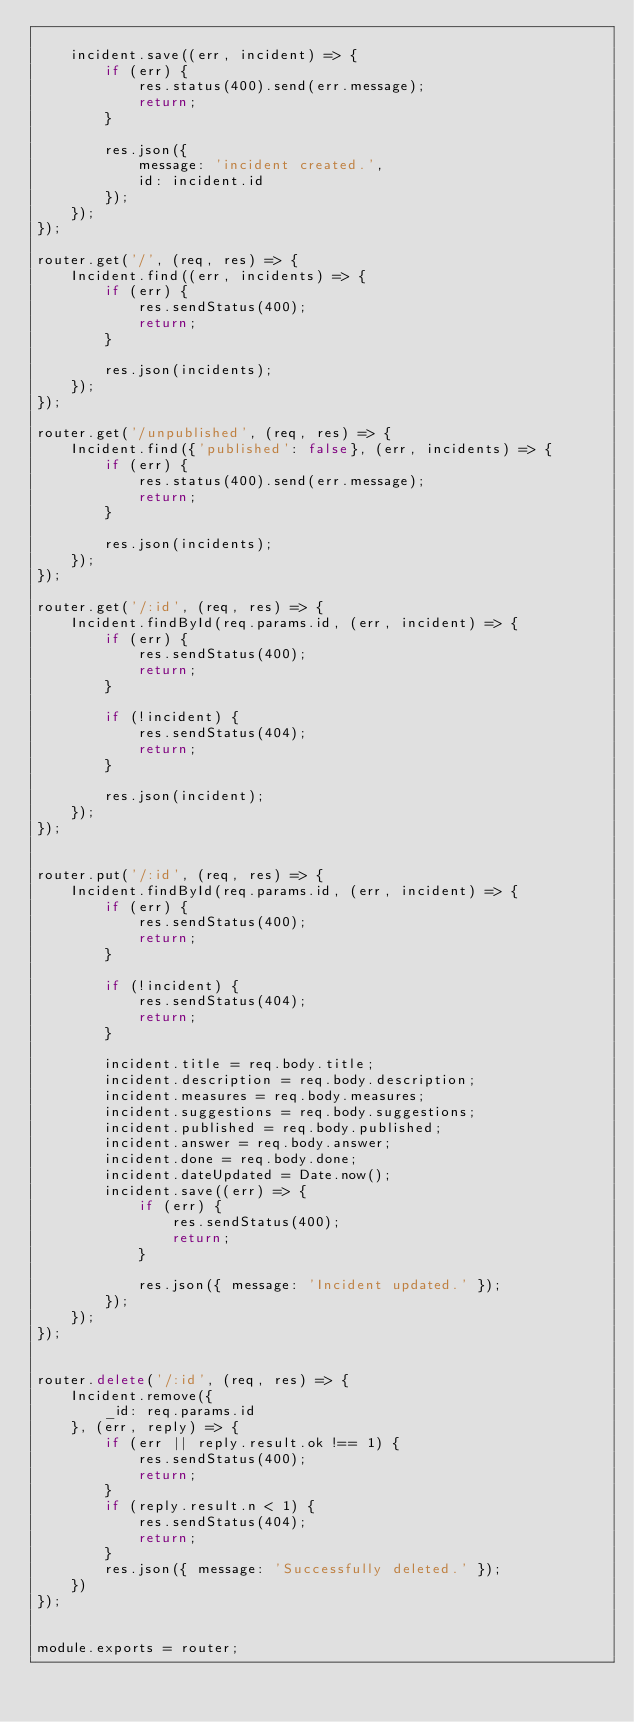<code> <loc_0><loc_0><loc_500><loc_500><_JavaScript_>
    incident.save((err, incident) => {
        if (err) {
            res.status(400).send(err.message);
            return;
        }

        res.json({
            message: 'incident created.',
            id: incident.id
        });
    });
});

router.get('/', (req, res) => {
    Incident.find((err, incidents) => {
        if (err) {
            res.sendStatus(400);
            return;
        }

        res.json(incidents);
    });
});

router.get('/unpublished', (req, res) => {
    Incident.find({'published': false}, (err, incidents) => {
        if (err) {
            res.status(400).send(err.message);
            return;
        }

        res.json(incidents);
    });
});

router.get('/:id', (req, res) => {
    Incident.findById(req.params.id, (err, incident) => {
        if (err) {
            res.sendStatus(400);
            return;
        }

        if (!incident) {
            res.sendStatus(404);
            return;
        }

        res.json(incident);
    });
});


router.put('/:id', (req, res) => {
    Incident.findById(req.params.id, (err, incident) => {
        if (err) {
            res.sendStatus(400);
            return;
        }

        if (!incident) {
            res.sendStatus(404);
            return;
        }

        incident.title = req.body.title;
        incident.description = req.body.description;
        incident.measures = req.body.measures;
        incident.suggestions = req.body.suggestions;
        incident.published = req.body.published;
        incident.answer = req.body.answer;
        incident.done = req.body.done;
        incident.dateUpdated = Date.now();
        incident.save((err) => {
            if (err) {
                res.sendStatus(400);
                return;
            }

            res.json({ message: 'Incident updated.' });
        });
    });
});


router.delete('/:id', (req, res) => {
    Incident.remove({
        _id: req.params.id
    }, (err, reply) => {
        if (err || reply.result.ok !== 1) {
            res.sendStatus(400);
            return;
        }
        if (reply.result.n < 1) {
            res.sendStatus(404);
            return;
        }
        res.json({ message: 'Successfully deleted.' });
    })
});


module.exports = router;
</code> 